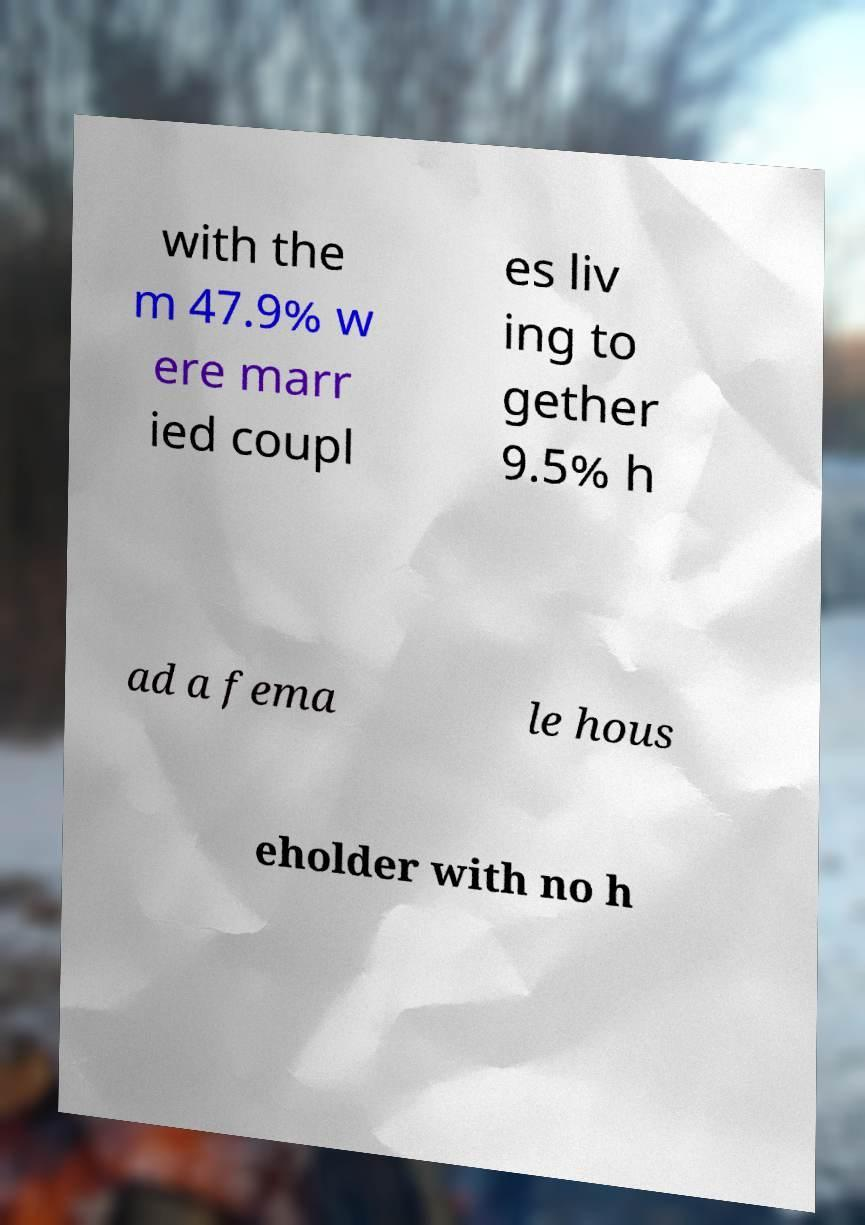What messages or text are displayed in this image? I need them in a readable, typed format. with the m 47.9% w ere marr ied coupl es liv ing to gether 9.5% h ad a fema le hous eholder with no h 